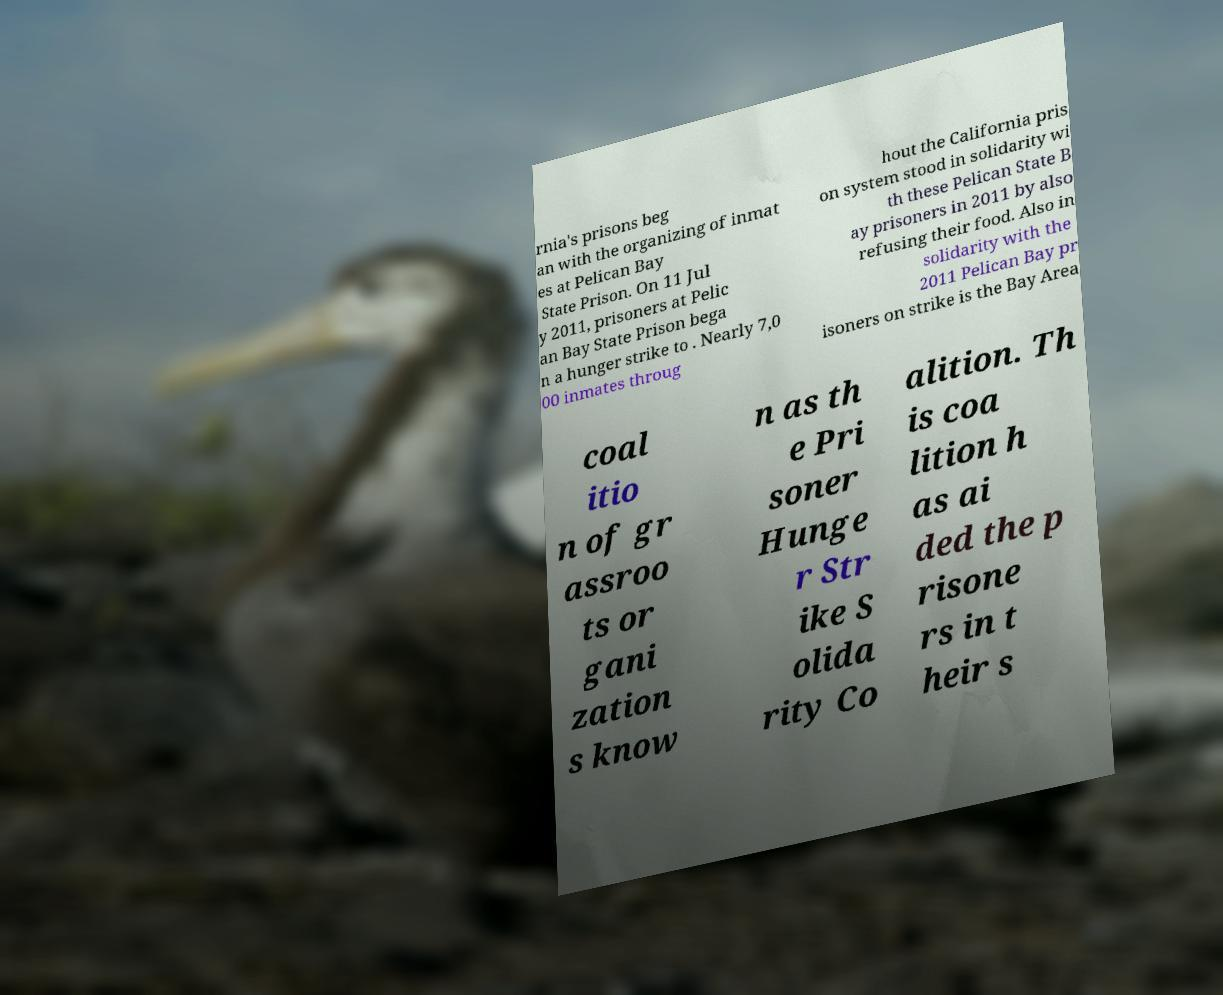There's text embedded in this image that I need extracted. Can you transcribe it verbatim? rnia's prisons beg an with the organizing of inmat es at Pelican Bay State Prison. On 11 Jul y 2011, prisoners at Pelic an Bay State Prison bega n a hunger strike to . Nearly 7,0 00 inmates throug hout the California pris on system stood in solidarity wi th these Pelican State B ay prisoners in 2011 by also refusing their food. Also in solidarity with the 2011 Pelican Bay pr isoners on strike is the Bay Area coal itio n of gr assroo ts or gani zation s know n as th e Pri soner Hunge r Str ike S olida rity Co alition. Th is coa lition h as ai ded the p risone rs in t heir s 